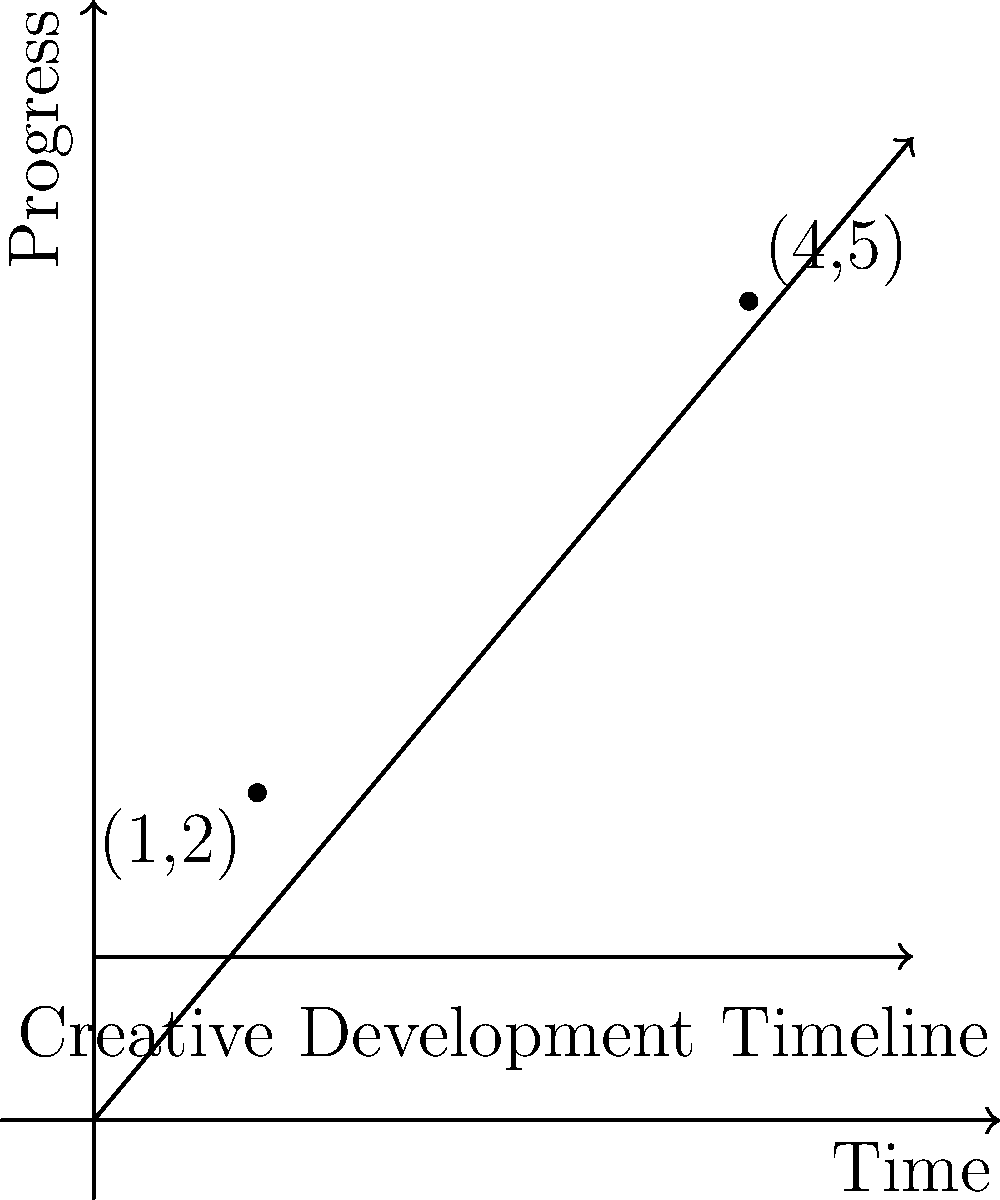In a copyright infringement lawsuit, you need to establish a timeline of creative development. Two key points in this timeline are represented by (1,2) and (4,5) on a graph where the x-axis represents time and the y-axis represents progress. What is the equation of the line passing through these two points, which could represent the continuous development of the creative work in question? To find the equation of a line passing through two points, we can use the point-slope form of a line equation. Here's how to solve it step by step:

1) The point-slope form is: $y - y_1 = m(x - x_1)$, where $m$ is the slope of the line.

2) Calculate the slope ($m$) using the two given points:
   $m = \frac{y_2 - y_1}{x_2 - x_1} = \frac{5 - 2}{4 - 1} = \frac{3}{3} = 1$

3) Now we have the slope, let's use the point (1,2) as $(x_1, y_1)$ in our equation:
   $y - 2 = 1(x - 1)$

4) Simplify by distributing the 1:
   $y - 2 = x - 1$

5) Add 2 to both sides to isolate $y$:
   $y = x - 1 + 2$

6) Simplify:
   $y = x + 1$

This equation $y = x + 1$ represents the line of creative development passing through the two given points on the timeline.
Answer: $y = x + 1$ 